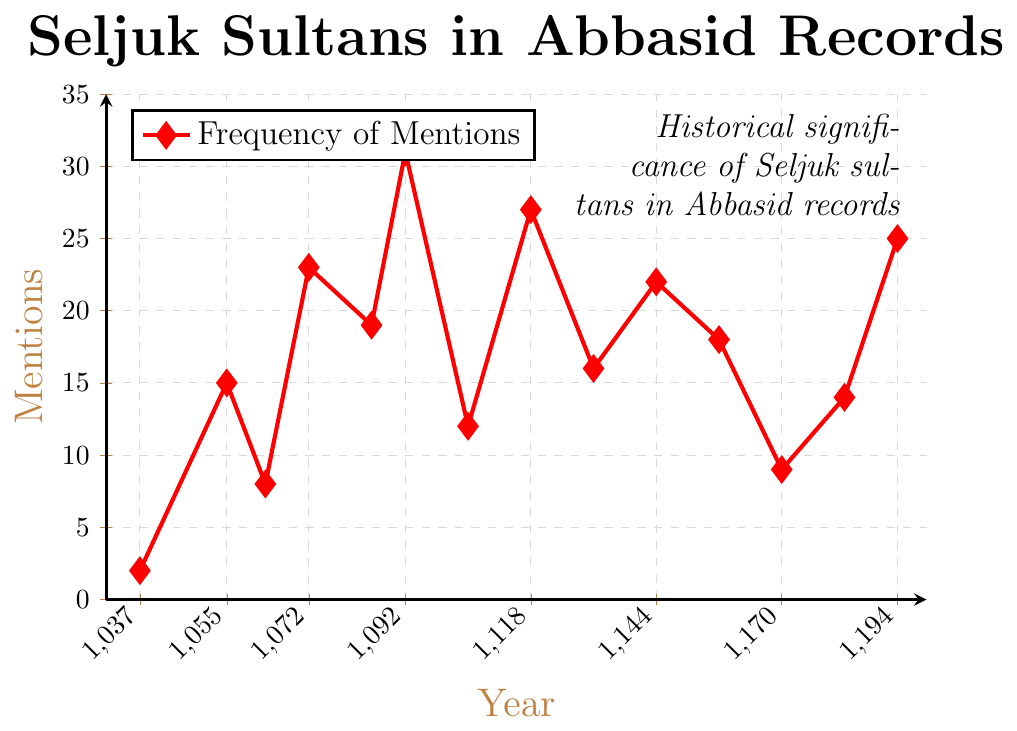What's the year with the highest frequency of mentions of Seljuk sultans in Abbasid historical records? To find the year with the highest frequency of mentions, observe the highest point on the line chart. The year corresponding to the peak is 1092 with 31 mentions.
Answer: 1092 How does the frequency of mentions in 1055 compare to that in 1194? To compare the mentions in 1055 and 1194, look at the y-values for both years. In 1055, there are 15 mentions, and in 1194, there are 25 mentions. 1194 has 10 more mentions than 1055.
Answer: Higher in 1194 by 10 What's the average frequency of mentions over all recorded years? Sum all the mentions and divide by the number of years. Total mentions = 2 + 15 + 8 + 23 + 19 + 31 + 12 + 27 + 16 + 22 + 18 + 9 + 14 + 25 = 221. Number of years = 14. Average = 221 / 14 ≈ 15.79
Answer: 15.79 In which year did the frequency of mentions first exceed 20? Check the y-values to find the first year where mentions exceed 20. The year is 1072 with 23 mentions.
Answer: 1072 Identify the year with the lowest frequency of mentions and provide its value. Look at the lowest point on the line chart. The year is 1037 with 2 mentions.
Answer: 1037, 2 What's the difference in the frequency of mentions between 1085 and 1105? Find the y-values for both 1085 and 1105. 1085 has 19 mentions, and 1105 has 12 mentions. The difference is 19 - 12 = 7.
Answer: 7 Which period saw a continuous increase in mentions, and what was the rise in that period? Identify a period where the line consistently goes up. From 1055 (15 mentions) to 1092 (31 mentions), the mentions increase. The rise is 31 - 15 = 16.
Answer: 1055 to 1092, rise of 16 Was there any period of decline in frequency from 1092 to 1194? Observe the trend from 1092 to 1194. After 1092, mentions decrease to 12 by 1105, then fluctuate, but overall trend includes declines, including from 1092 to 1105.
Answer: Yes, multiple periods including 1092 to 1105 Compare the frequency of mentions in 1072 and 1144. Which year had more mentions and by how much? Look at the y-values. In 1072, there were 23 mentions. In 1144, there were 22 mentions. 1072 had 1 more mention than 1144.
Answer: 1072, by 1 